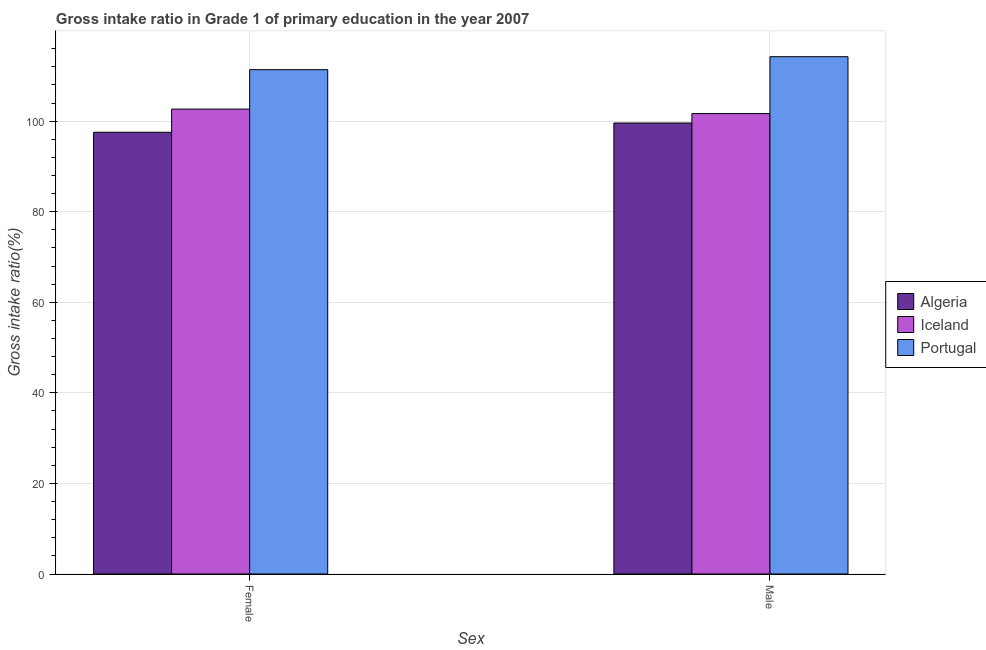How many different coloured bars are there?
Your response must be concise. 3. How many bars are there on the 2nd tick from the left?
Ensure brevity in your answer.  3. How many bars are there on the 2nd tick from the right?
Ensure brevity in your answer.  3. What is the gross intake ratio(female) in Algeria?
Keep it short and to the point. 97.56. Across all countries, what is the maximum gross intake ratio(female)?
Give a very brief answer. 111.38. Across all countries, what is the minimum gross intake ratio(female)?
Provide a succinct answer. 97.56. In which country was the gross intake ratio(male) maximum?
Keep it short and to the point. Portugal. In which country was the gross intake ratio(female) minimum?
Your answer should be very brief. Algeria. What is the total gross intake ratio(female) in the graph?
Keep it short and to the point. 311.62. What is the difference between the gross intake ratio(male) in Portugal and that in Iceland?
Offer a terse response. 12.56. What is the difference between the gross intake ratio(female) in Iceland and the gross intake ratio(male) in Algeria?
Keep it short and to the point. 3.07. What is the average gross intake ratio(female) per country?
Your response must be concise. 103.87. What is the difference between the gross intake ratio(female) and gross intake ratio(male) in Portugal?
Ensure brevity in your answer.  -2.87. In how many countries, is the gross intake ratio(male) greater than 76 %?
Your answer should be very brief. 3. What is the ratio of the gross intake ratio(male) in Portugal to that in Algeria?
Ensure brevity in your answer.  1.15. Is the gross intake ratio(female) in Portugal less than that in Algeria?
Make the answer very short. No. What does the 3rd bar from the left in Male represents?
Offer a very short reply. Portugal. What does the 2nd bar from the right in Female represents?
Ensure brevity in your answer.  Iceland. How many bars are there?
Provide a succinct answer. 6. Are all the bars in the graph horizontal?
Offer a terse response. No. Does the graph contain any zero values?
Make the answer very short. No. How many legend labels are there?
Offer a terse response. 3. What is the title of the graph?
Offer a very short reply. Gross intake ratio in Grade 1 of primary education in the year 2007. Does "United States" appear as one of the legend labels in the graph?
Offer a terse response. No. What is the label or title of the X-axis?
Offer a terse response. Sex. What is the label or title of the Y-axis?
Your answer should be compact. Gross intake ratio(%). What is the Gross intake ratio(%) of Algeria in Female?
Your answer should be very brief. 97.56. What is the Gross intake ratio(%) in Iceland in Female?
Provide a succinct answer. 102.68. What is the Gross intake ratio(%) in Portugal in Female?
Your response must be concise. 111.38. What is the Gross intake ratio(%) in Algeria in Male?
Your answer should be very brief. 99.61. What is the Gross intake ratio(%) of Iceland in Male?
Provide a succinct answer. 101.69. What is the Gross intake ratio(%) in Portugal in Male?
Provide a short and direct response. 114.25. Across all Sex, what is the maximum Gross intake ratio(%) of Algeria?
Your answer should be compact. 99.61. Across all Sex, what is the maximum Gross intake ratio(%) in Iceland?
Provide a succinct answer. 102.68. Across all Sex, what is the maximum Gross intake ratio(%) in Portugal?
Provide a short and direct response. 114.25. Across all Sex, what is the minimum Gross intake ratio(%) of Algeria?
Ensure brevity in your answer.  97.56. Across all Sex, what is the minimum Gross intake ratio(%) of Iceland?
Your answer should be compact. 101.69. Across all Sex, what is the minimum Gross intake ratio(%) of Portugal?
Your answer should be very brief. 111.38. What is the total Gross intake ratio(%) of Algeria in the graph?
Offer a terse response. 197.17. What is the total Gross intake ratio(%) in Iceland in the graph?
Provide a succinct answer. 204.37. What is the total Gross intake ratio(%) of Portugal in the graph?
Keep it short and to the point. 225.63. What is the difference between the Gross intake ratio(%) of Algeria in Female and that in Male?
Provide a succinct answer. -2.04. What is the difference between the Gross intake ratio(%) of Iceland in Female and that in Male?
Offer a terse response. 0.99. What is the difference between the Gross intake ratio(%) in Portugal in Female and that in Male?
Offer a terse response. -2.87. What is the difference between the Gross intake ratio(%) of Algeria in Female and the Gross intake ratio(%) of Iceland in Male?
Provide a succinct answer. -4.13. What is the difference between the Gross intake ratio(%) of Algeria in Female and the Gross intake ratio(%) of Portugal in Male?
Keep it short and to the point. -16.69. What is the difference between the Gross intake ratio(%) in Iceland in Female and the Gross intake ratio(%) in Portugal in Male?
Your answer should be compact. -11.57. What is the average Gross intake ratio(%) in Algeria per Sex?
Offer a very short reply. 98.58. What is the average Gross intake ratio(%) in Iceland per Sex?
Ensure brevity in your answer.  102.18. What is the average Gross intake ratio(%) in Portugal per Sex?
Offer a very short reply. 112.82. What is the difference between the Gross intake ratio(%) in Algeria and Gross intake ratio(%) in Iceland in Female?
Offer a very short reply. -5.12. What is the difference between the Gross intake ratio(%) of Algeria and Gross intake ratio(%) of Portugal in Female?
Make the answer very short. -13.82. What is the difference between the Gross intake ratio(%) in Iceland and Gross intake ratio(%) in Portugal in Female?
Offer a very short reply. -8.7. What is the difference between the Gross intake ratio(%) of Algeria and Gross intake ratio(%) of Iceland in Male?
Keep it short and to the point. -2.08. What is the difference between the Gross intake ratio(%) in Algeria and Gross intake ratio(%) in Portugal in Male?
Your response must be concise. -14.64. What is the difference between the Gross intake ratio(%) in Iceland and Gross intake ratio(%) in Portugal in Male?
Ensure brevity in your answer.  -12.56. What is the ratio of the Gross intake ratio(%) in Algeria in Female to that in Male?
Give a very brief answer. 0.98. What is the ratio of the Gross intake ratio(%) of Iceland in Female to that in Male?
Make the answer very short. 1.01. What is the ratio of the Gross intake ratio(%) of Portugal in Female to that in Male?
Offer a terse response. 0.97. What is the difference between the highest and the second highest Gross intake ratio(%) of Algeria?
Your answer should be compact. 2.04. What is the difference between the highest and the second highest Gross intake ratio(%) in Portugal?
Provide a succinct answer. 2.87. What is the difference between the highest and the lowest Gross intake ratio(%) of Algeria?
Keep it short and to the point. 2.04. What is the difference between the highest and the lowest Gross intake ratio(%) in Portugal?
Offer a very short reply. 2.87. 